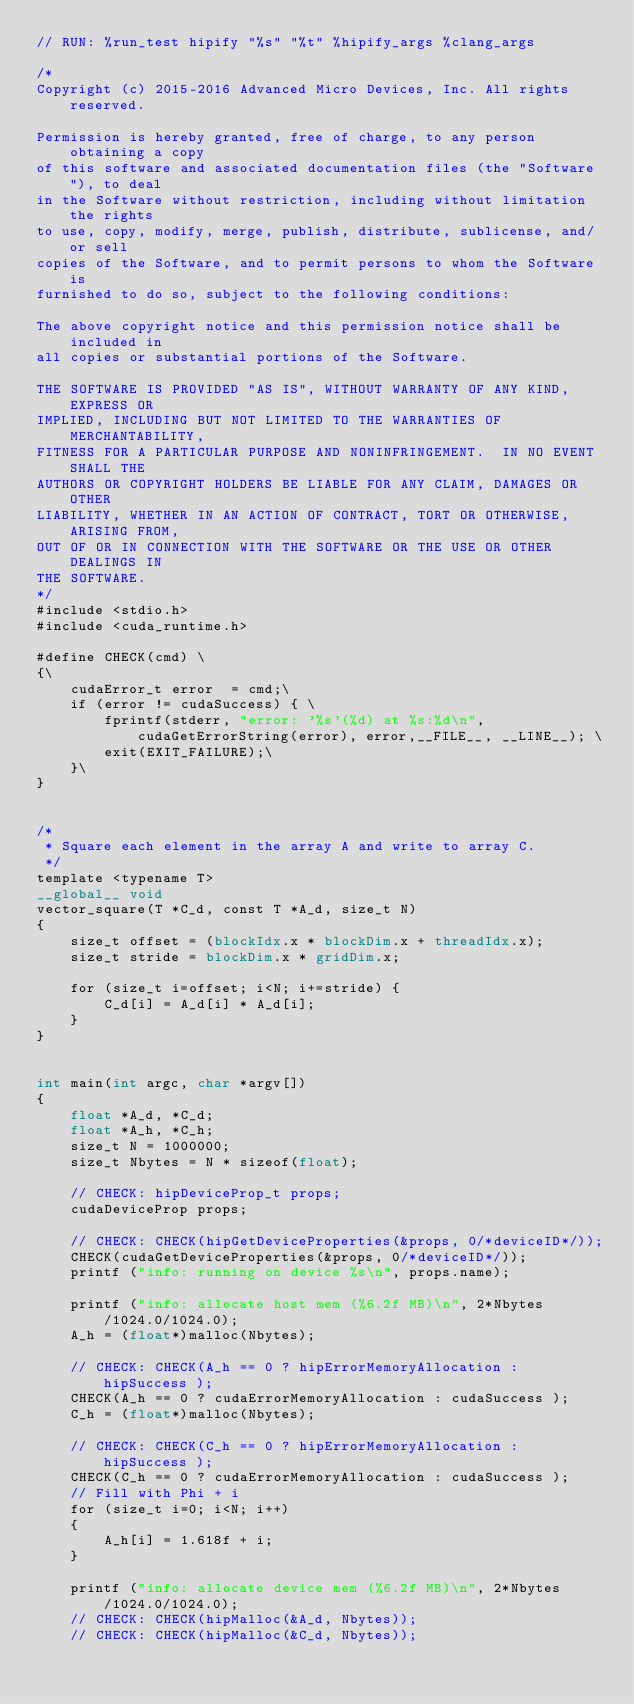Convert code to text. <code><loc_0><loc_0><loc_500><loc_500><_Cuda_>// RUN: %run_test hipify "%s" "%t" %hipify_args %clang_args

/*
Copyright (c) 2015-2016 Advanced Micro Devices, Inc. All rights reserved.

Permission is hereby granted, free of charge, to any person obtaining a copy
of this software and associated documentation files (the "Software"), to deal
in the Software without restriction, including without limitation the rights
to use, copy, modify, merge, publish, distribute, sublicense, and/or sell
copies of the Software, and to permit persons to whom the Software is
furnished to do so, subject to the following conditions:

The above copyright notice and this permission notice shall be included in
all copies or substantial portions of the Software.

THE SOFTWARE IS PROVIDED "AS IS", WITHOUT WARRANTY OF ANY KIND, EXPRESS OR
IMPLIED, INCLUDING BUT NOT LIMITED TO THE WARRANTIES OF MERCHANTABILITY,
FITNESS FOR A PARTICULAR PURPOSE AND NONINFRINGEMENT.  IN NO EVENT SHALL THE
AUTHORS OR COPYRIGHT HOLDERS BE LIABLE FOR ANY CLAIM, DAMAGES OR OTHER
LIABILITY, WHETHER IN AN ACTION OF CONTRACT, TORT OR OTHERWISE, ARISING FROM,
OUT OF OR IN CONNECTION WITH THE SOFTWARE OR THE USE OR OTHER DEALINGS IN
THE SOFTWARE.
*/
#include <stdio.h>
#include <cuda_runtime.h>

#define CHECK(cmd) \
{\
    cudaError_t error  = cmd;\
    if (error != cudaSuccess) { \
        fprintf(stderr, "error: '%s'(%d) at %s:%d\n", cudaGetErrorString(error), error,__FILE__, __LINE__); \
        exit(EXIT_FAILURE);\
	  }\
}


/*
 * Square each element in the array A and write to array C.
 */
template <typename T>
__global__ void
vector_square(T *C_d, const T *A_d, size_t N)
{
    size_t offset = (blockIdx.x * blockDim.x + threadIdx.x);
    size_t stride = blockDim.x * gridDim.x;

    for (size_t i=offset; i<N; i+=stride) {
        C_d[i] = A_d[i] * A_d[i];
    }
}


int main(int argc, char *argv[])
{
    float *A_d, *C_d;
    float *A_h, *C_h;
    size_t N = 1000000;
    size_t Nbytes = N * sizeof(float);

    // CHECK: hipDeviceProp_t props;
    cudaDeviceProp props;

    // CHECK: CHECK(hipGetDeviceProperties(&props, 0/*deviceID*/));
    CHECK(cudaGetDeviceProperties(&props, 0/*deviceID*/));
    printf ("info: running on device %s\n", props.name);

    printf ("info: allocate host mem (%6.2f MB)\n", 2*Nbytes/1024.0/1024.0);
    A_h = (float*)malloc(Nbytes);

    // CHECK: CHECK(A_h == 0 ? hipErrorMemoryAllocation : hipSuccess );
    CHECK(A_h == 0 ? cudaErrorMemoryAllocation : cudaSuccess );
    C_h = (float*)malloc(Nbytes);

    // CHECK: CHECK(C_h == 0 ? hipErrorMemoryAllocation : hipSuccess );
    CHECK(C_h == 0 ? cudaErrorMemoryAllocation : cudaSuccess );
    // Fill with Phi + i
    for (size_t i=0; i<N; i++)
    {
        A_h[i] = 1.618f + i;
    }

    printf ("info: allocate device mem (%6.2f MB)\n", 2*Nbytes/1024.0/1024.0);
    // CHECK: CHECK(hipMalloc(&A_d, Nbytes));
    // CHECK: CHECK(hipMalloc(&C_d, Nbytes));</code> 